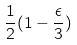Convert formula to latex. <formula><loc_0><loc_0><loc_500><loc_500>\frac { 1 } { 2 } ( 1 - \frac { \epsilon } { 3 } )</formula> 